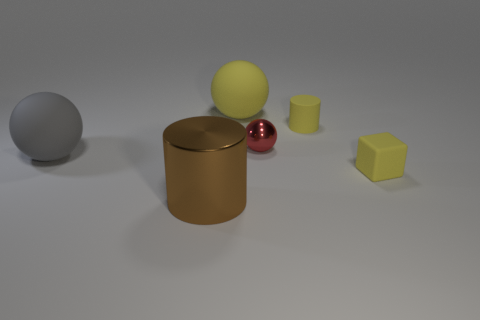Add 3 large things. How many objects exist? 9 Subtract all cylinders. How many objects are left? 4 Add 5 brown things. How many brown things exist? 6 Subtract 0 green balls. How many objects are left? 6 Subtract all blocks. Subtract all tiny yellow matte cylinders. How many objects are left? 4 Add 4 large brown cylinders. How many large brown cylinders are left? 5 